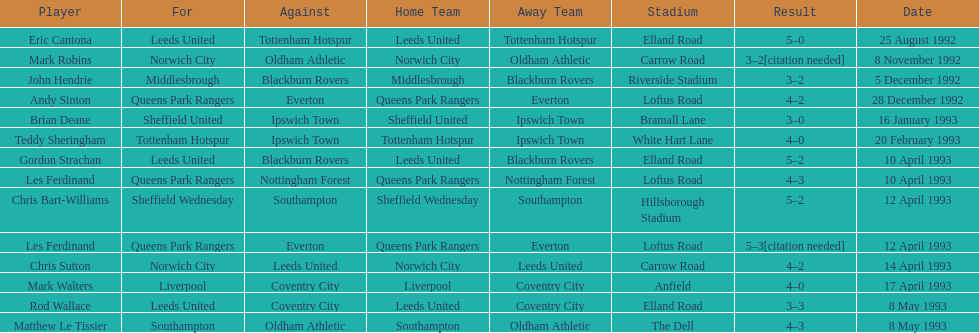How many players were for leeds united? 3. 